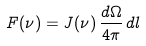Convert formula to latex. <formula><loc_0><loc_0><loc_500><loc_500>F ( \nu ) = J ( \nu ) \, \frac { d \Omega } { 4 \pi } \, d l</formula> 